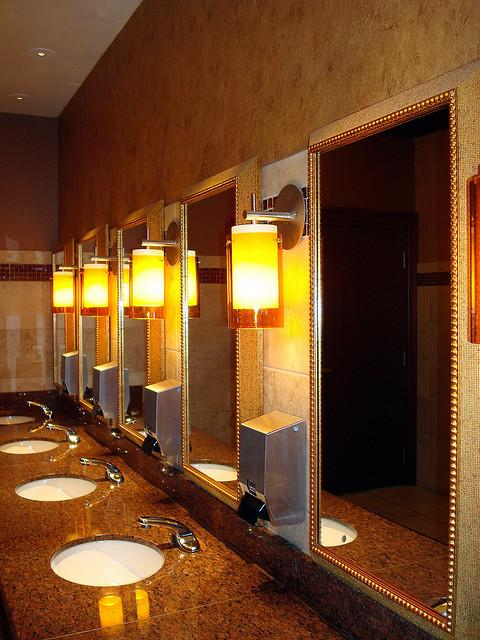What are the metal boxes on the wall used for? soap 